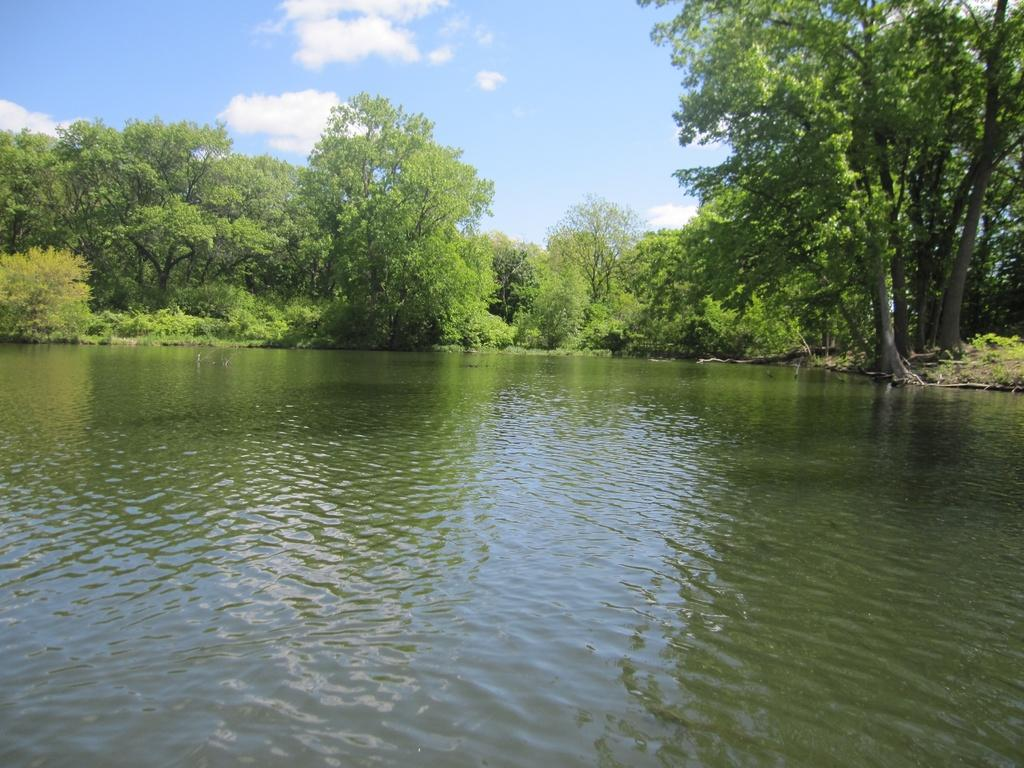What is the main feature at the bottom of the image? There is a surface of water at the bottom of the image. What can be seen in the middle of the image? Trees are present in the middle of the image. How would you describe the sky in the background of the image? The sky is cloudy in the background of the image. What type of song can be heard coming from the monkey in the image? There is no monkey present in the image, so it's not possible to determine what, if any, song might be heard. 